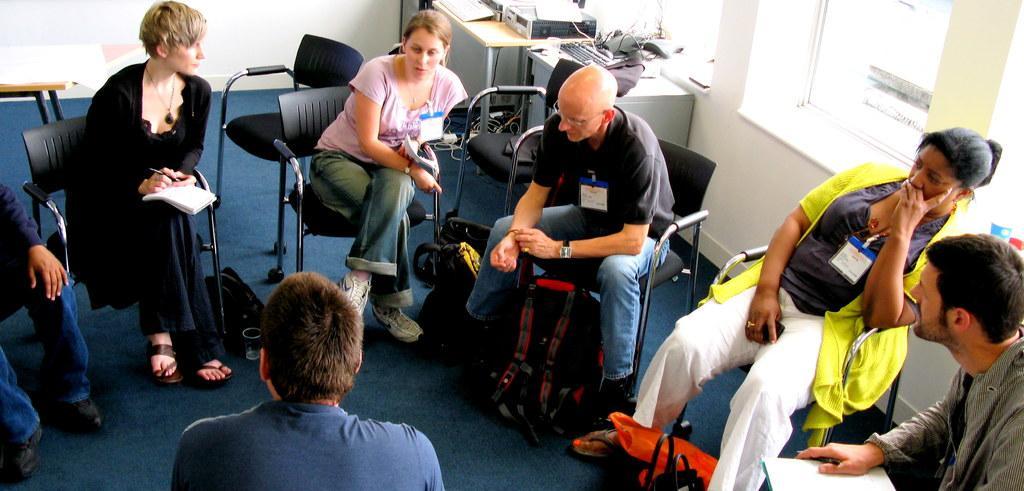How would you summarize this image in a sentence or two? In this picture I can see few people who are sitting on chairs and I see few bags on the floor. In the background I can see an empty chair, tables on which there are few things and I see that it is white color on the right of this picture. 